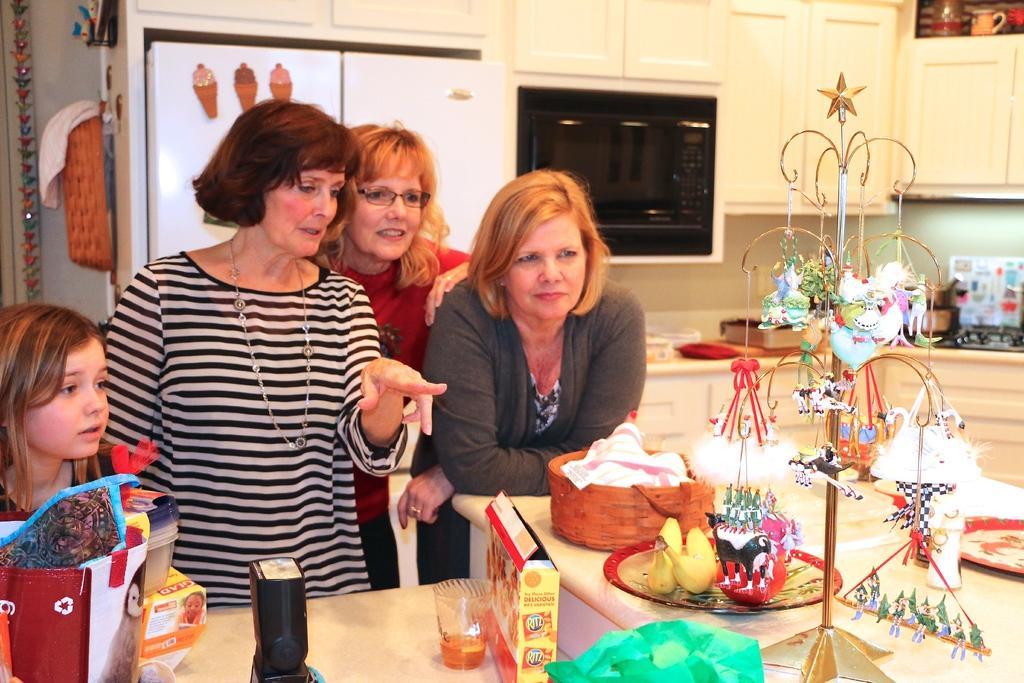How would you summarize this image in a sentence or two? In this image, we can see some people standing and there are some objects kept on the table. In the background, we can see some cupboards and there is an oven and we can see the fridge. 